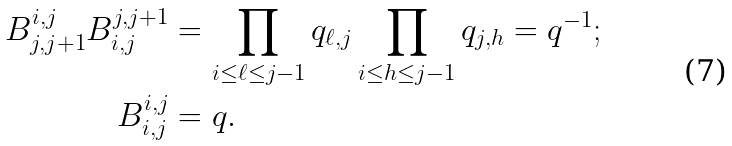Convert formula to latex. <formula><loc_0><loc_0><loc_500><loc_500>B ^ { i , j } _ { j , j + 1 } B _ { i , j } ^ { j , j + 1 } & = \prod _ { i \leq \ell \leq j - 1 } q _ { \ell , j } \prod _ { i \leq h \leq j - 1 } q _ { j , h } = q ^ { - 1 } ; \\ B _ { i , j } ^ { i , j } & = q .</formula> 